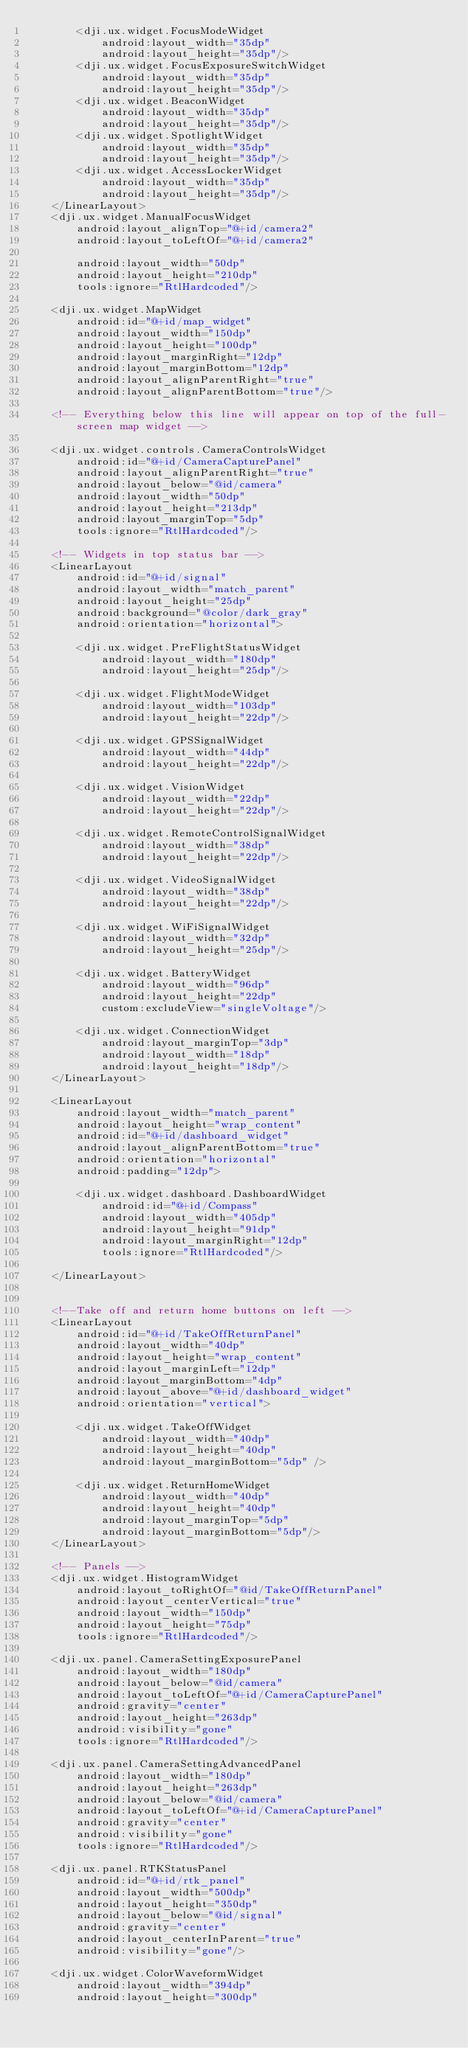Convert code to text. <code><loc_0><loc_0><loc_500><loc_500><_XML_>        <dji.ux.widget.FocusModeWidget
            android:layout_width="35dp"
            android:layout_height="35dp"/>
        <dji.ux.widget.FocusExposureSwitchWidget
            android:layout_width="35dp"
            android:layout_height="35dp"/>
        <dji.ux.widget.BeaconWidget
            android:layout_width="35dp"
            android:layout_height="35dp"/>
        <dji.ux.widget.SpotlightWidget
            android:layout_width="35dp"
            android:layout_height="35dp"/>
        <dji.ux.widget.AccessLockerWidget
            android:layout_width="35dp"
            android:layout_height="35dp"/>
    </LinearLayout>
    <dji.ux.widget.ManualFocusWidget
        android:layout_alignTop="@+id/camera2"
        android:layout_toLeftOf="@+id/camera2"

        android:layout_width="50dp"
        android:layout_height="210dp"
        tools:ignore="RtlHardcoded"/>

    <dji.ux.widget.MapWidget
        android:id="@+id/map_widget"
        android:layout_width="150dp"
        android:layout_height="100dp"
        android:layout_marginRight="12dp"
        android:layout_marginBottom="12dp"
        android:layout_alignParentRight="true"
        android:layout_alignParentBottom="true"/>

    <!-- Everything below this line will appear on top of the full-screen map widget -->

    <dji.ux.widget.controls.CameraControlsWidget
        android:id="@+id/CameraCapturePanel"
        android:layout_alignParentRight="true"
        android:layout_below="@id/camera"
        android:layout_width="50dp"
        android:layout_height="213dp"
        android:layout_marginTop="5dp"
        tools:ignore="RtlHardcoded"/>

    <!-- Widgets in top status bar -->
    <LinearLayout
        android:id="@+id/signal"
        android:layout_width="match_parent"
        android:layout_height="25dp"
        android:background="@color/dark_gray"
        android:orientation="horizontal">

        <dji.ux.widget.PreFlightStatusWidget
            android:layout_width="180dp"
            android:layout_height="25dp"/>

        <dji.ux.widget.FlightModeWidget
            android:layout_width="103dp"
            android:layout_height="22dp"/>

        <dji.ux.widget.GPSSignalWidget
            android:layout_width="44dp"
            android:layout_height="22dp"/>

        <dji.ux.widget.VisionWidget
            android:layout_width="22dp"
            android:layout_height="22dp"/>

        <dji.ux.widget.RemoteControlSignalWidget
            android:layout_width="38dp"
            android:layout_height="22dp"/>

        <dji.ux.widget.VideoSignalWidget
            android:layout_width="38dp"
            android:layout_height="22dp"/>

        <dji.ux.widget.WiFiSignalWidget
            android:layout_width="32dp"
            android:layout_height="25dp"/>

        <dji.ux.widget.BatteryWidget
            android:layout_width="96dp"
            android:layout_height="22dp"
            custom:excludeView="singleVoltage"/>

        <dji.ux.widget.ConnectionWidget
            android:layout_marginTop="3dp"
            android:layout_width="18dp"
            android:layout_height="18dp"/>
    </LinearLayout>

    <LinearLayout
        android:layout_width="match_parent"
        android:layout_height="wrap_content"
        android:id="@+id/dashboard_widget"
        android:layout_alignParentBottom="true"
        android:orientation="horizontal"
        android:padding="12dp">

        <dji.ux.widget.dashboard.DashboardWidget
            android:id="@+id/Compass"
            android:layout_width="405dp"
            android:layout_height="91dp"
            android:layout_marginRight="12dp"
            tools:ignore="RtlHardcoded"/>

    </LinearLayout>


    <!--Take off and return home buttons on left -->
    <LinearLayout
        android:id="@+id/TakeOffReturnPanel"
        android:layout_width="40dp"
        android:layout_height="wrap_content"
        android:layout_marginLeft="12dp"
        android:layout_marginBottom="4dp"
        android:layout_above="@+id/dashboard_widget"
        android:orientation="vertical">

        <dji.ux.widget.TakeOffWidget
            android:layout_width="40dp"
            android:layout_height="40dp"
            android:layout_marginBottom="5dp" />

        <dji.ux.widget.ReturnHomeWidget
            android:layout_width="40dp"
            android:layout_height="40dp"
            android:layout_marginTop="5dp"
            android:layout_marginBottom="5dp"/>
    </LinearLayout>

    <!-- Panels -->
    <dji.ux.widget.HistogramWidget
        android:layout_toRightOf="@id/TakeOffReturnPanel"
        android:layout_centerVertical="true"
        android:layout_width="150dp"
        android:layout_height="75dp"
        tools:ignore="RtlHardcoded"/>

    <dji.ux.panel.CameraSettingExposurePanel
        android:layout_width="180dp"
        android:layout_below="@id/camera"
        android:layout_toLeftOf="@+id/CameraCapturePanel"
        android:gravity="center"
        android:layout_height="263dp"
        android:visibility="gone"
        tools:ignore="RtlHardcoded"/>

    <dji.ux.panel.CameraSettingAdvancedPanel
        android:layout_width="180dp"
        android:layout_height="263dp"
        android:layout_below="@id/camera"
        android:layout_toLeftOf="@+id/CameraCapturePanel"
        android:gravity="center"
        android:visibility="gone"
        tools:ignore="RtlHardcoded"/>

    <dji.ux.panel.RTKStatusPanel
        android:id="@+id/rtk_panel"
        android:layout_width="500dp"
        android:layout_height="350dp"
        android:layout_below="@id/signal"
        android:gravity="center"
        android:layout_centerInParent="true"
        android:visibility="gone"/>

    <dji.ux.widget.ColorWaveformWidget
        android:layout_width="394dp"
        android:layout_height="300dp"</code> 